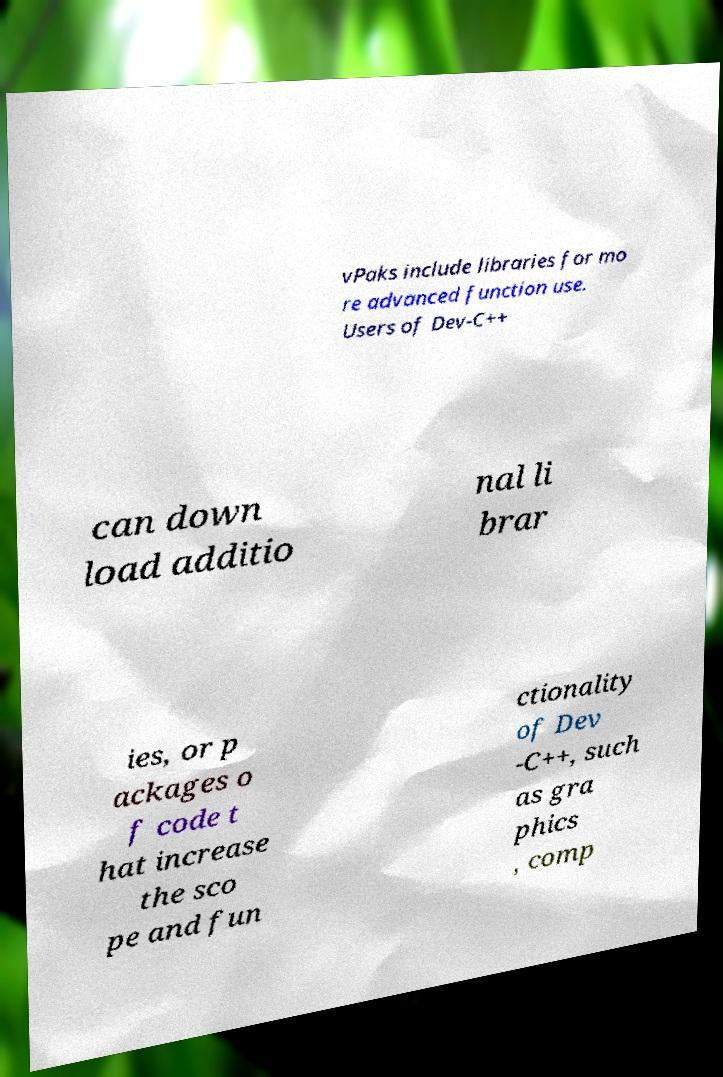Please identify and transcribe the text found in this image. vPaks include libraries for mo re advanced function use. Users of Dev-C++ can down load additio nal li brar ies, or p ackages o f code t hat increase the sco pe and fun ctionality of Dev -C++, such as gra phics , comp 